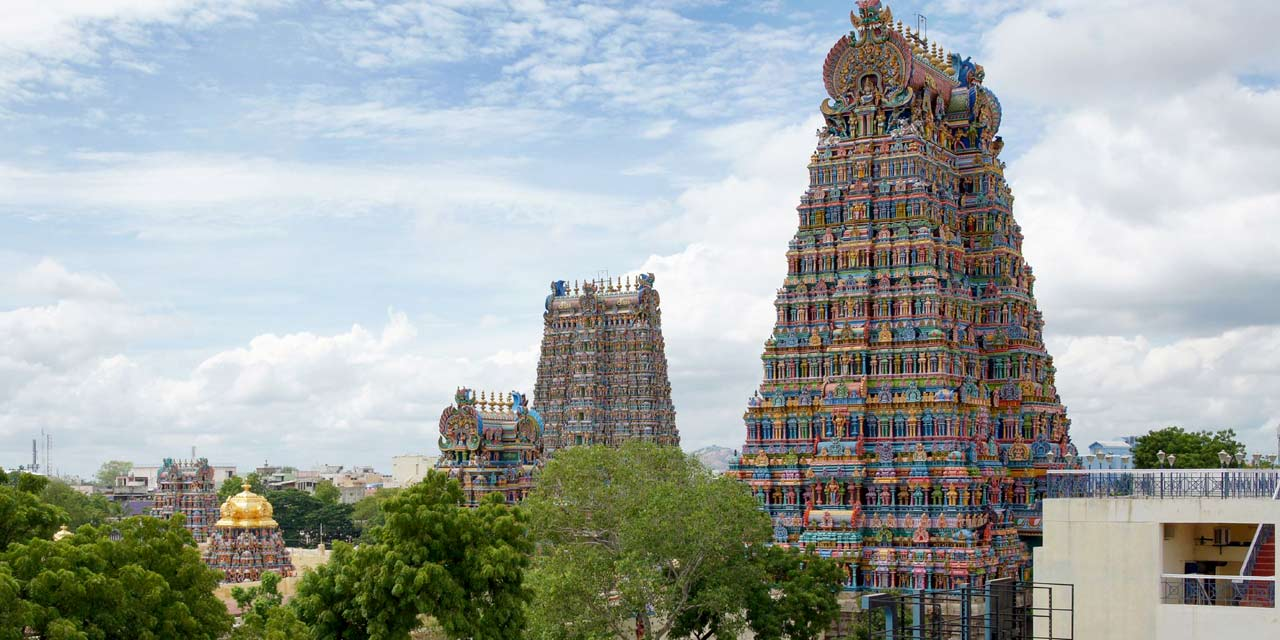What architectural features make this temple unique? The Meenakshi Amman Temple is renowned for its distinctive architectural features, primarily its towering gopurams which are a hallmark of Dravidian architecture. Each gopuram is intricately decorated with thousands of colorful statues often depicting gods, goddesses, mythical beings, and stories from Hindu mythology. The tallest gopuram, the Southern Tower, is especially impressive, standing at approximately 170 feet tall. Inside, the temple complex houses numerous shrines, a thousand-pillared hall (Ayiram Kaal Mandapam) adorned with detailed carvings, and several spacious corridors and sacred tanks such as the Potramarai Kulam. The meticulous attention to detail, elaborate designs, and vibrant use of color make this temple a unique marvel of historical and cultural significance. How do the statues and carvings contribute to the temple's overall impact? The statues and carvings at the Meenakshi Amman Temple are fundamental to its overall impact, transforming it into a living gallery of art and mythology. Each statue and carving tells a story, depicting various scenes and deities from Hindu legends that serve both religious and educational purposes. The vivid colors and fine craftsmanship of these sculptures not only enhance the temple's visual appeal but also bring to life the rich cultural heritage and spiritual narratives of the region. The sheer number and variety of these sculptures create a sense of awe, inviting worshippers and visitors to immerse themselves in the history and spirituality that the temple represents. Together, they make the temple a vibrant, dynamic space that celebrates the artistic and religious aspirations of its builders. 